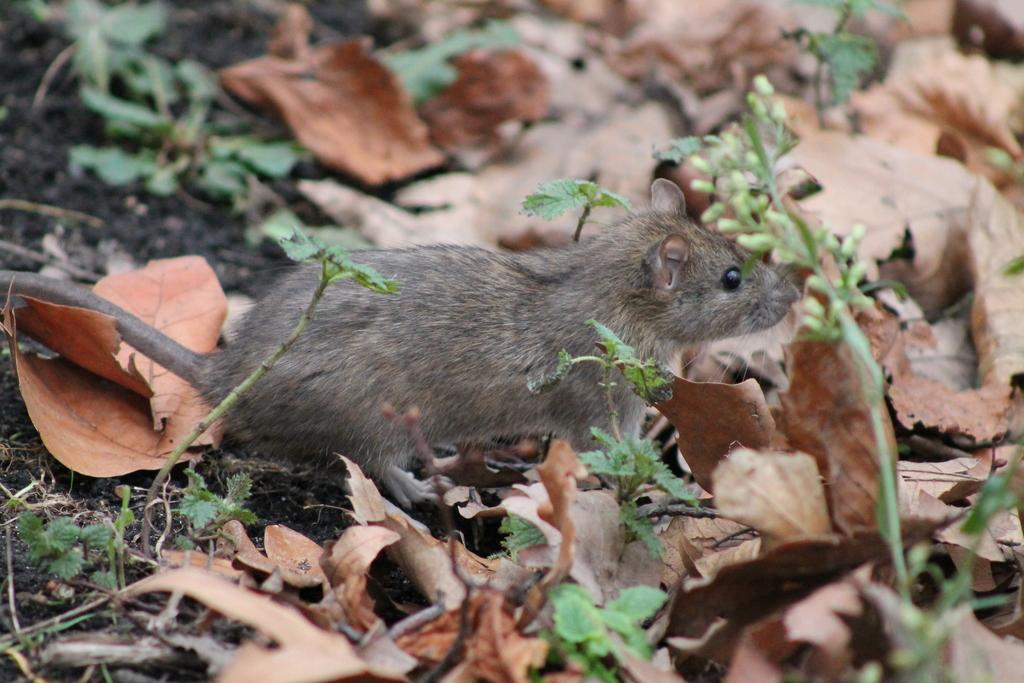What type of animal can be seen in the picture? There is a mouse in the picture. What type of vegetation is present in the picture? There is grass in the picture, and leaves on the ground. What type of honey can be seen dripping from the branch in the picture? There is no honey or branch present in the picture; it only features a mouse and vegetation. 